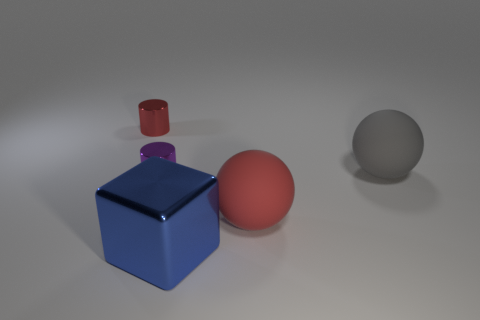There is a large object that is behind the ball that is on the left side of the large gray sphere; what shape is it?
Provide a succinct answer. Sphere. What shape is the tiny shiny thing behind the big gray rubber ball?
Provide a succinct answer. Cylinder. Is the color of the shiny thing that is behind the tiny purple cylinder the same as the matte ball that is in front of the small purple cylinder?
Your answer should be compact. Yes. How many objects are both right of the block and behind the big red sphere?
Offer a terse response. 1. There is another sphere that is the same material as the red sphere; what size is it?
Give a very brief answer. Large. The red cylinder is what size?
Your answer should be compact. Small. What material is the blue thing?
Offer a terse response. Metal. There is a red thing that is on the left side of the blue block; is its size the same as the big red matte object?
Give a very brief answer. No. What number of objects are either small red cylinders or tiny yellow matte blocks?
Ensure brevity in your answer.  1. There is a thing that is to the left of the blue metal thing and on the right side of the small red metal object; what size is it?
Your answer should be compact. Small. 